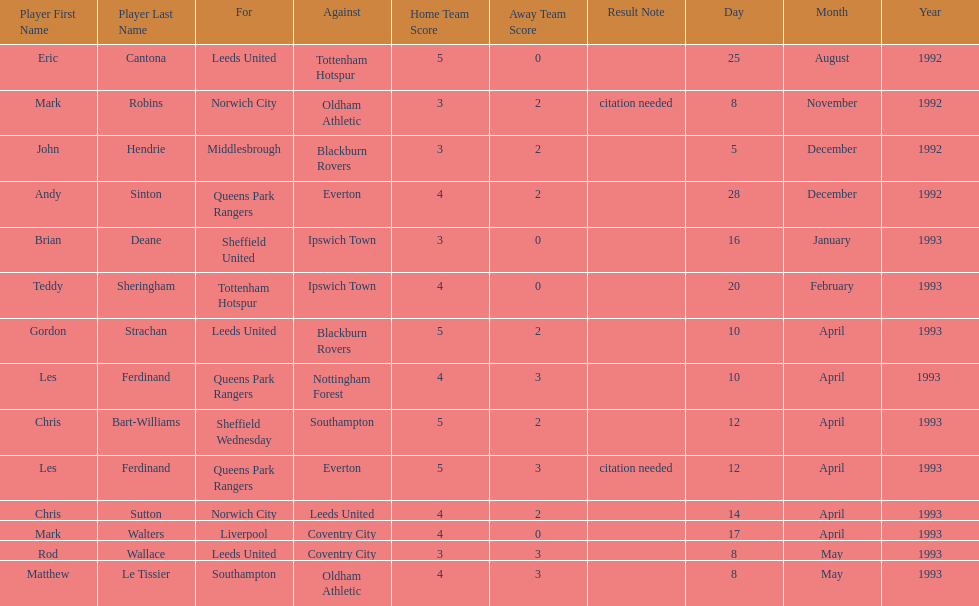Which team did liverpool play against? Coventry City. 